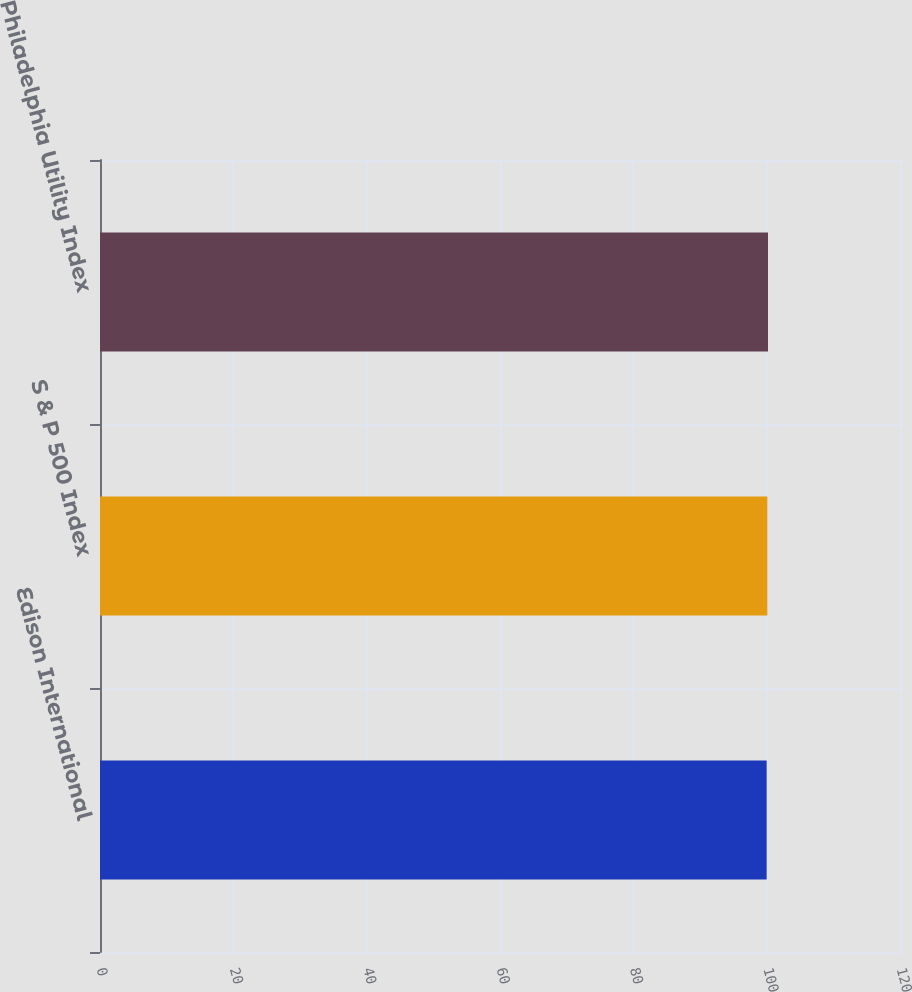Convert chart to OTSL. <chart><loc_0><loc_0><loc_500><loc_500><bar_chart><fcel>Edison International<fcel>S & P 500 Index<fcel>Philadelphia Utility Index<nl><fcel>100<fcel>100.1<fcel>100.2<nl></chart> 